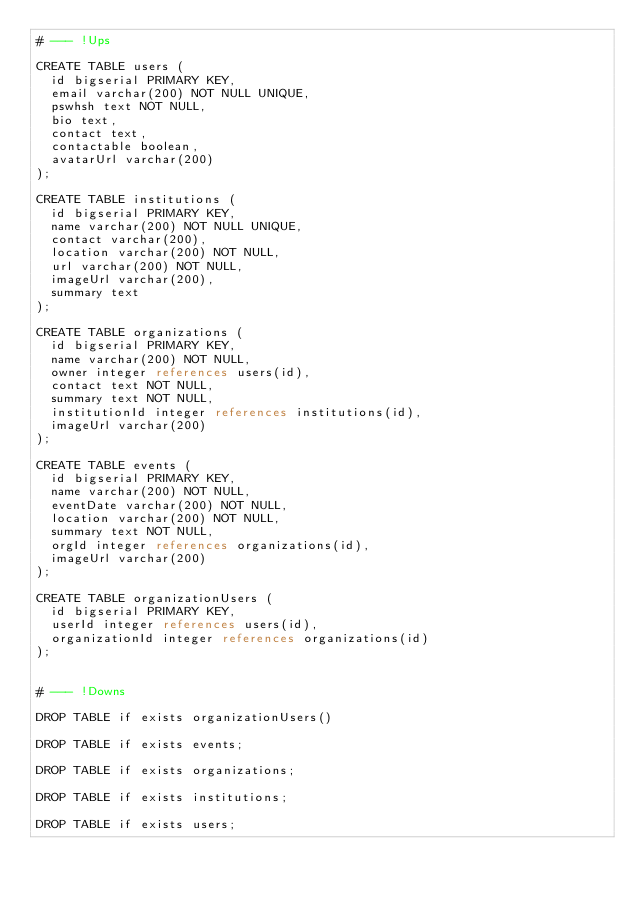<code> <loc_0><loc_0><loc_500><loc_500><_SQL_># --- !Ups

CREATE TABLE users (
	id bigserial PRIMARY KEY,
	email varchar(200) NOT NULL UNIQUE,
	pswhsh text NOT NULL,
	bio text,
	contact text,
	contactable boolean,
	avatarUrl varchar(200)
);

CREATE TABLE institutions (
	id bigserial PRIMARY KEY,
	name varchar(200) NOT NULL UNIQUE,
	contact varchar(200),
	location varchar(200) NOT NULL,
	url varchar(200) NOT NULL,
	imageUrl varchar(200),
	summary text
);

CREATE TABLE organizations (
	id bigserial PRIMARY KEY,
	name varchar(200) NOT NULL,
	owner integer references users(id),
	contact text NOT NULL,
	summary text NOT NULL,
	institutionId integer references institutions(id),
	imageUrl varchar(200)
);

CREATE TABLE events (
	id bigserial PRIMARY KEY,
	name varchar(200) NOT NULL,
	eventDate varchar(200) NOT NULL,
	location varchar(200) NOT NULL,
	summary text NOT NULL,
	orgId integer references organizations(id),
	imageUrl varchar(200)
);

CREATE TABLE organizationUsers (
	id bigserial PRIMARY KEY,
	userId integer references users(id),
	organizationId integer references organizations(id)
);


# --- !Downs

DROP TABLE if exists organizationUsers()

DROP TABLE if exists events;

DROP TABLE if exists organizations;

DROP TABLE if exists institutions;

DROP TABLE if exists users;
</code> 